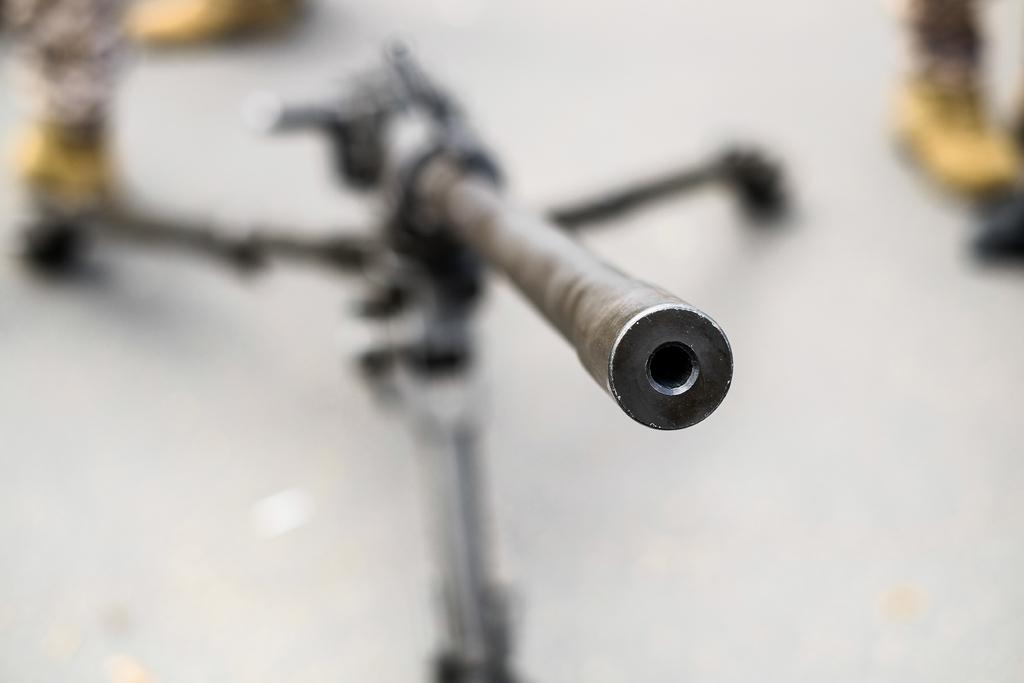What is the main object in the image? There is a camera stand in the image. Can you describe the background of the image? The background of the image is blurred. How many hens are visible in the image? There are no hens present in the image. What type of air is depicted in the image? There is no air depicted in the image; it is a still image of a camera stand. 